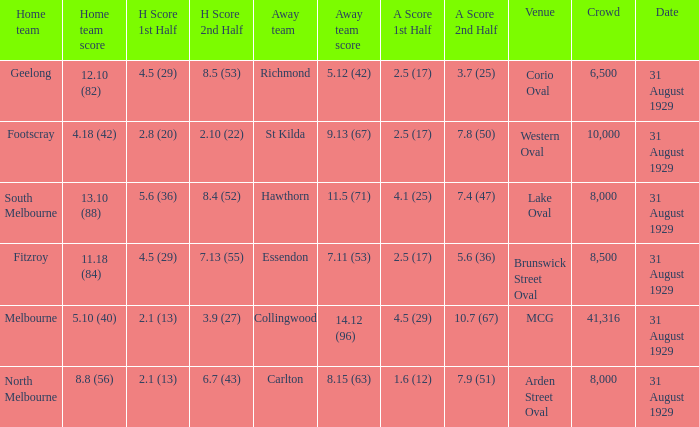What is the score of the away team when the crowd was larger than 8,000? 9.13 (67), 7.11 (53), 14.12 (96). 